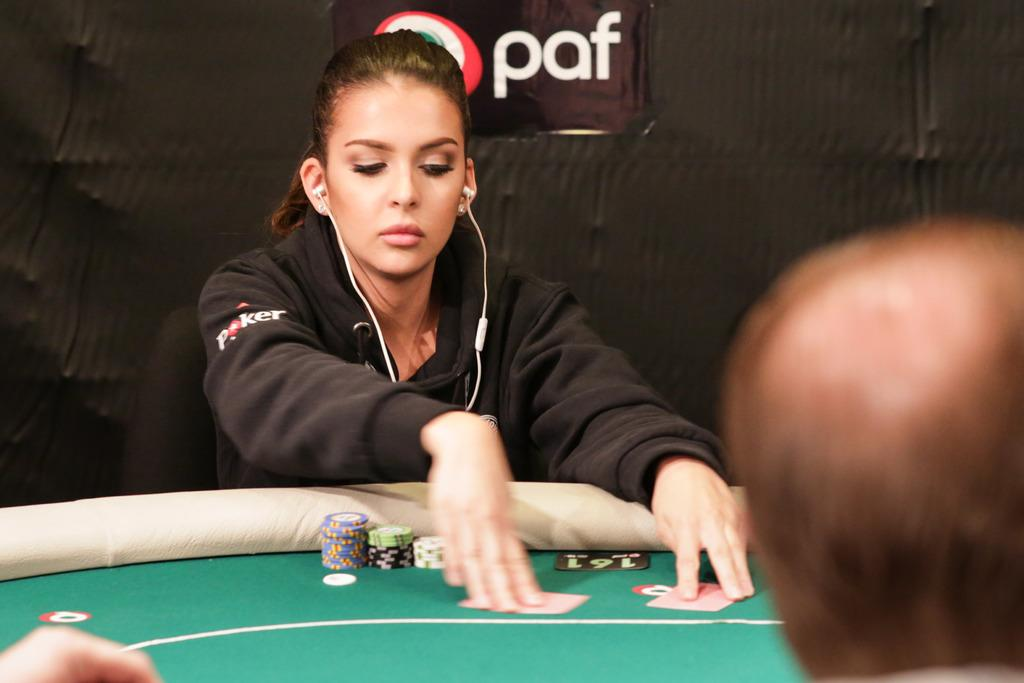Who is present in the image? There is a woman in the image. What can be seen in the background of the image? There is a cloth in the background of the image. Where is the downtown area in the image? There is no downtown area present in the image. What type of balloon can be seen floating in the background? There is no balloon present in the image. 